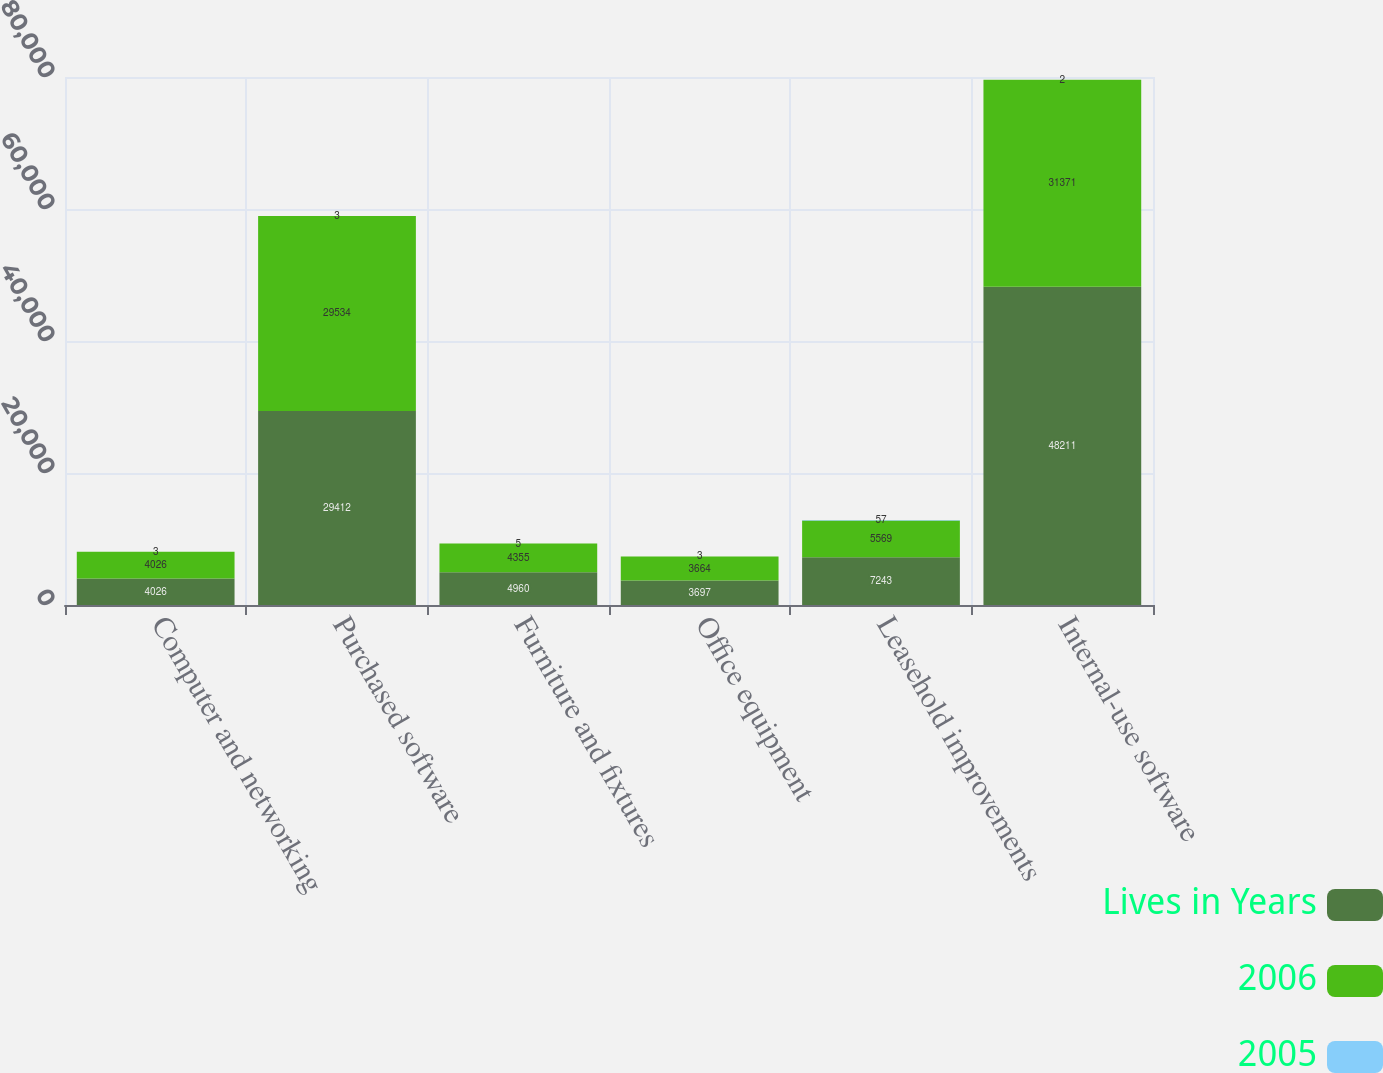Convert chart. <chart><loc_0><loc_0><loc_500><loc_500><stacked_bar_chart><ecel><fcel>Computer and networking<fcel>Purchased software<fcel>Furniture and fixtures<fcel>Office equipment<fcel>Leasehold improvements<fcel>Internal-use software<nl><fcel>Lives in Years<fcel>4026<fcel>29412<fcel>4960<fcel>3697<fcel>7243<fcel>48211<nl><fcel>2006<fcel>4026<fcel>29534<fcel>4355<fcel>3664<fcel>5569<fcel>31371<nl><fcel>2005<fcel>3<fcel>3<fcel>5<fcel>3<fcel>57<fcel>2<nl></chart> 